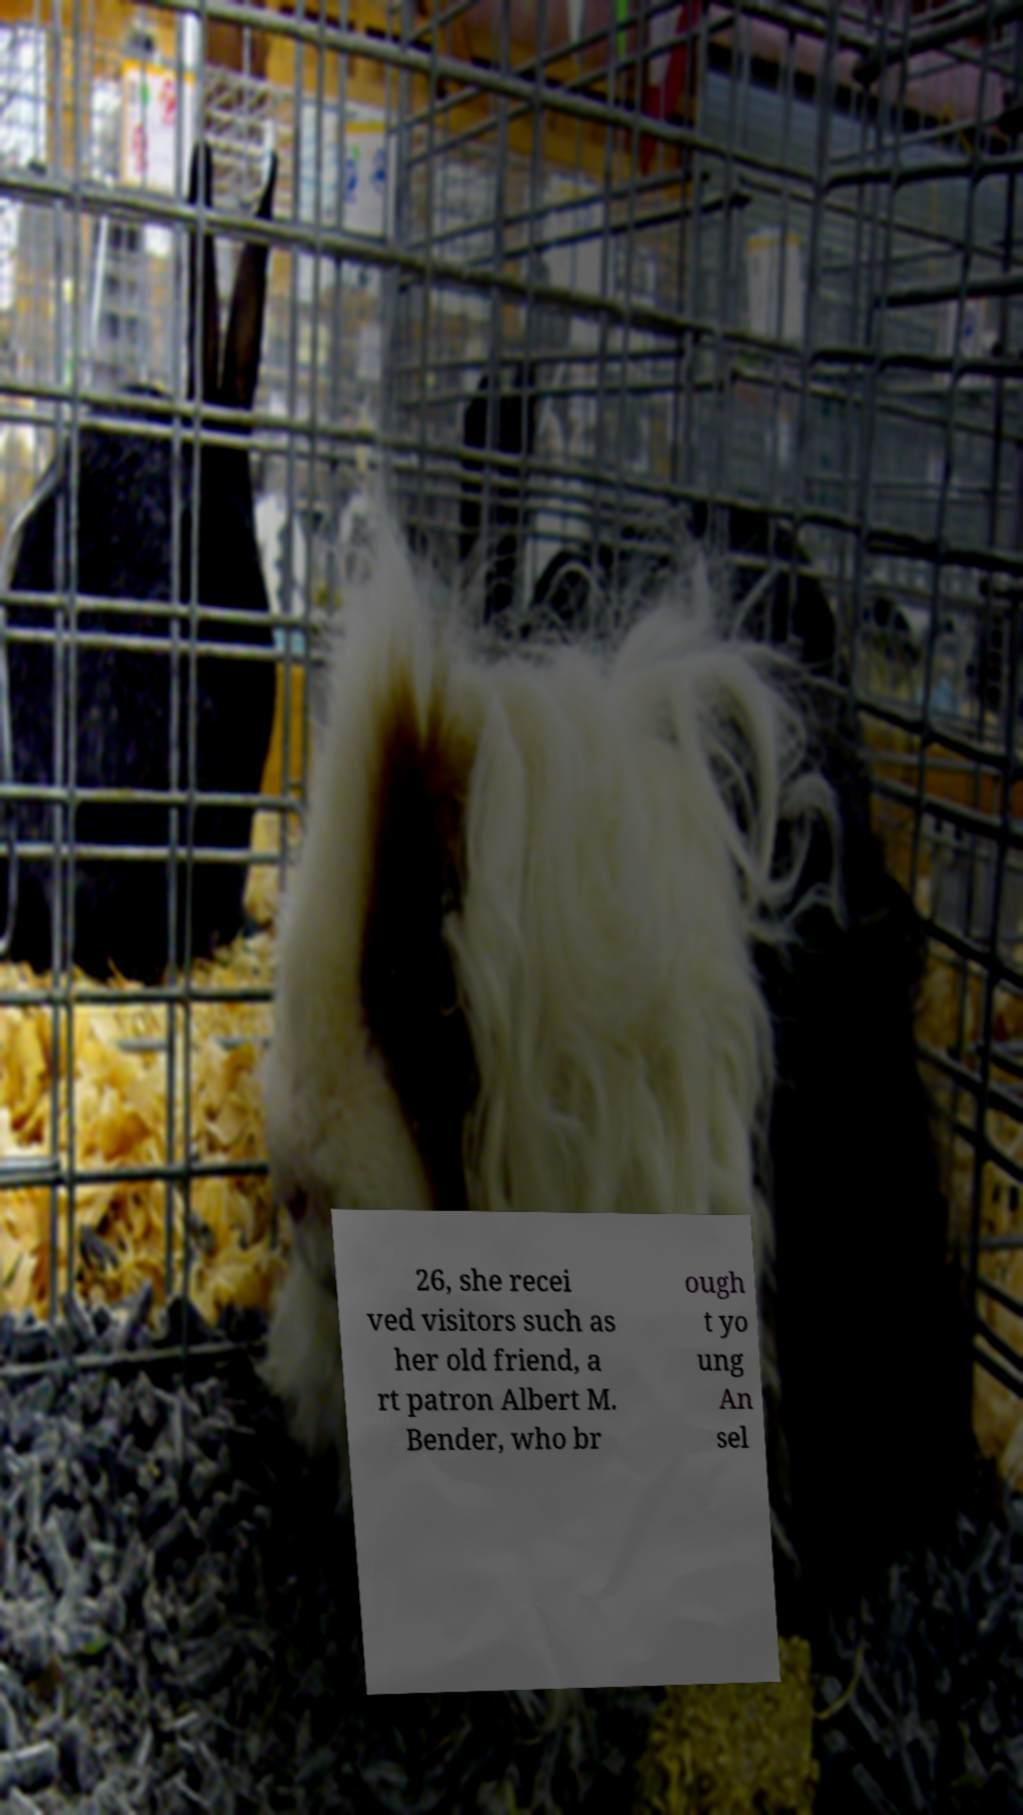Please identify and transcribe the text found in this image. 26, she recei ved visitors such as her old friend, a rt patron Albert M. Bender, who br ough t yo ung An sel 